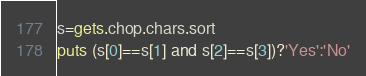Convert code to text. <code><loc_0><loc_0><loc_500><loc_500><_Ruby_>s=gets.chop.chars.sort
puts (s[0]==s[1] and s[2]==s[3])?'Yes':'No'</code> 